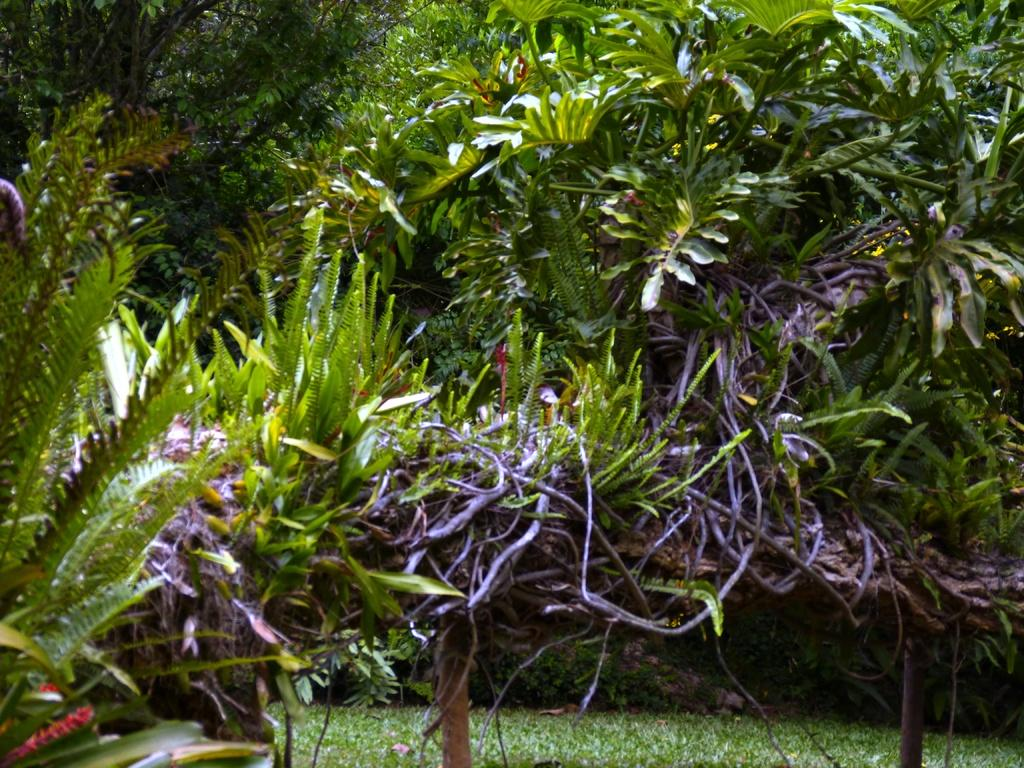What is the main subject of the image? The main subject of the image is a group of plants. Can you describe the color of some of the plants? Some of the plants are blue in color. What type of surface is under the plants? There is a grass surface under the plants. How many parcels are being delivered to the building in the image? There is no building or parcels present in the image; it features a group of plants on a grass surface. 